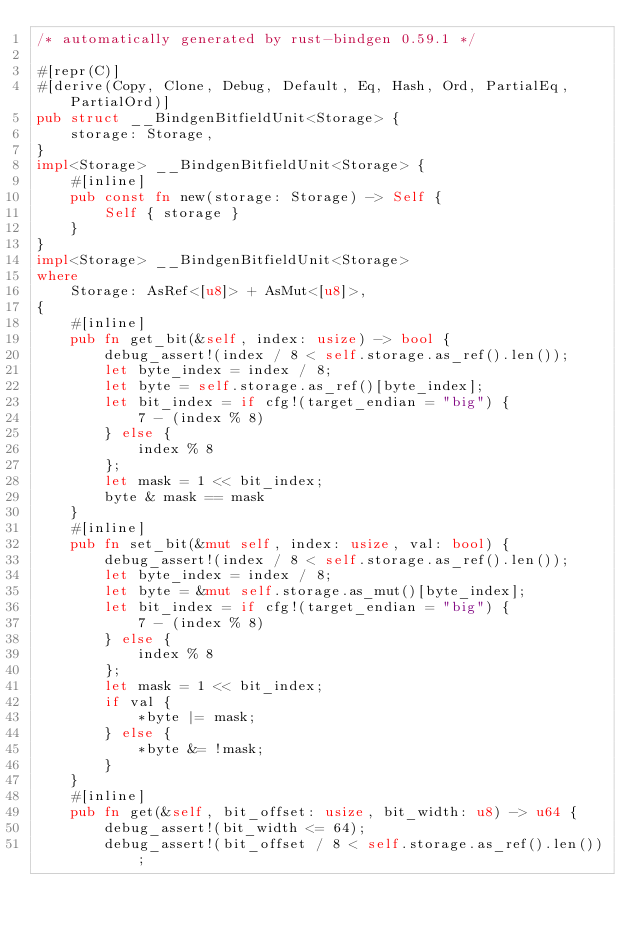<code> <loc_0><loc_0><loc_500><loc_500><_Rust_>/* automatically generated by rust-bindgen 0.59.1 */

#[repr(C)]
#[derive(Copy, Clone, Debug, Default, Eq, Hash, Ord, PartialEq, PartialOrd)]
pub struct __BindgenBitfieldUnit<Storage> {
    storage: Storage,
}
impl<Storage> __BindgenBitfieldUnit<Storage> {
    #[inline]
    pub const fn new(storage: Storage) -> Self {
        Self { storage }
    }
}
impl<Storage> __BindgenBitfieldUnit<Storage>
where
    Storage: AsRef<[u8]> + AsMut<[u8]>,
{
    #[inline]
    pub fn get_bit(&self, index: usize) -> bool {
        debug_assert!(index / 8 < self.storage.as_ref().len());
        let byte_index = index / 8;
        let byte = self.storage.as_ref()[byte_index];
        let bit_index = if cfg!(target_endian = "big") {
            7 - (index % 8)
        } else {
            index % 8
        };
        let mask = 1 << bit_index;
        byte & mask == mask
    }
    #[inline]
    pub fn set_bit(&mut self, index: usize, val: bool) {
        debug_assert!(index / 8 < self.storage.as_ref().len());
        let byte_index = index / 8;
        let byte = &mut self.storage.as_mut()[byte_index];
        let bit_index = if cfg!(target_endian = "big") {
            7 - (index % 8)
        } else {
            index % 8
        };
        let mask = 1 << bit_index;
        if val {
            *byte |= mask;
        } else {
            *byte &= !mask;
        }
    }
    #[inline]
    pub fn get(&self, bit_offset: usize, bit_width: u8) -> u64 {
        debug_assert!(bit_width <= 64);
        debug_assert!(bit_offset / 8 < self.storage.as_ref().len());</code> 